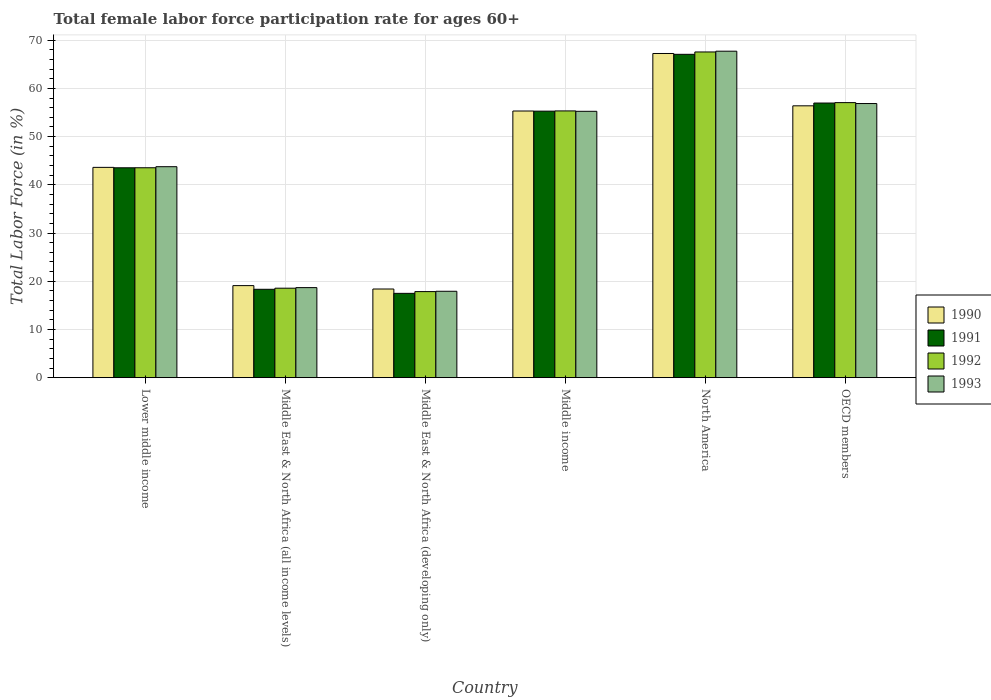What is the label of the 2nd group of bars from the left?
Your answer should be compact. Middle East & North Africa (all income levels). In how many cases, is the number of bars for a given country not equal to the number of legend labels?
Make the answer very short. 0. What is the female labor force participation rate in 1991 in Middle East & North Africa (all income levels)?
Make the answer very short. 18.33. Across all countries, what is the maximum female labor force participation rate in 1993?
Provide a short and direct response. 67.71. Across all countries, what is the minimum female labor force participation rate in 1990?
Your response must be concise. 18.39. In which country was the female labor force participation rate in 1993 maximum?
Ensure brevity in your answer.  North America. In which country was the female labor force participation rate in 1993 minimum?
Your response must be concise. Middle East & North Africa (developing only). What is the total female labor force participation rate in 1992 in the graph?
Offer a very short reply. 259.87. What is the difference between the female labor force participation rate in 1992 in Lower middle income and that in North America?
Give a very brief answer. -24.01. What is the difference between the female labor force participation rate in 1991 in Middle East & North Africa (developing only) and the female labor force participation rate in 1992 in Middle income?
Make the answer very short. -37.84. What is the average female labor force participation rate in 1991 per country?
Your answer should be compact. 43.11. What is the difference between the female labor force participation rate of/in 1990 and female labor force participation rate of/in 1991 in Middle income?
Ensure brevity in your answer.  0.03. In how many countries, is the female labor force participation rate in 1992 greater than 52 %?
Offer a very short reply. 3. What is the ratio of the female labor force participation rate in 1993 in Middle East & North Africa (all income levels) to that in OECD members?
Your answer should be very brief. 0.33. Is the female labor force participation rate in 1990 in Middle East & North Africa (all income levels) less than that in Middle East & North Africa (developing only)?
Make the answer very short. No. Is the difference between the female labor force participation rate in 1990 in Middle East & North Africa (all income levels) and Middle East & North Africa (developing only) greater than the difference between the female labor force participation rate in 1991 in Middle East & North Africa (all income levels) and Middle East & North Africa (developing only)?
Offer a terse response. No. What is the difference between the highest and the second highest female labor force participation rate in 1992?
Give a very brief answer. -10.51. What is the difference between the highest and the lowest female labor force participation rate in 1992?
Provide a succinct answer. 49.7. Is it the case that in every country, the sum of the female labor force participation rate in 1992 and female labor force participation rate in 1993 is greater than the female labor force participation rate in 1990?
Make the answer very short. Yes. How many countries are there in the graph?
Your answer should be very brief. 6. What is the difference between two consecutive major ticks on the Y-axis?
Ensure brevity in your answer.  10. Are the values on the major ticks of Y-axis written in scientific E-notation?
Your answer should be very brief. No. How many legend labels are there?
Your answer should be very brief. 4. How are the legend labels stacked?
Offer a very short reply. Vertical. What is the title of the graph?
Make the answer very short. Total female labor force participation rate for ages 60+. What is the label or title of the Y-axis?
Give a very brief answer. Total Labor Force (in %). What is the Total Labor Force (in %) of 1990 in Lower middle income?
Your answer should be compact. 43.62. What is the Total Labor Force (in %) in 1991 in Lower middle income?
Your answer should be compact. 43.53. What is the Total Labor Force (in %) in 1992 in Lower middle income?
Provide a succinct answer. 43.54. What is the Total Labor Force (in %) in 1993 in Lower middle income?
Give a very brief answer. 43.76. What is the Total Labor Force (in %) of 1990 in Middle East & North Africa (all income levels)?
Ensure brevity in your answer.  19.09. What is the Total Labor Force (in %) in 1991 in Middle East & North Africa (all income levels)?
Offer a very short reply. 18.33. What is the Total Labor Force (in %) of 1992 in Middle East & North Africa (all income levels)?
Your response must be concise. 18.56. What is the Total Labor Force (in %) in 1993 in Middle East & North Africa (all income levels)?
Offer a very short reply. 18.68. What is the Total Labor Force (in %) of 1990 in Middle East & North Africa (developing only)?
Offer a terse response. 18.39. What is the Total Labor Force (in %) in 1991 in Middle East & North Africa (developing only)?
Make the answer very short. 17.49. What is the Total Labor Force (in %) in 1992 in Middle East & North Africa (developing only)?
Your answer should be very brief. 17.85. What is the Total Labor Force (in %) in 1993 in Middle East & North Africa (developing only)?
Offer a terse response. 17.92. What is the Total Labor Force (in %) of 1990 in Middle income?
Your response must be concise. 55.31. What is the Total Labor Force (in %) in 1991 in Middle income?
Your response must be concise. 55.28. What is the Total Labor Force (in %) of 1992 in Middle income?
Keep it short and to the point. 55.33. What is the Total Labor Force (in %) in 1993 in Middle income?
Provide a succinct answer. 55.24. What is the Total Labor Force (in %) of 1990 in North America?
Provide a short and direct response. 67.23. What is the Total Labor Force (in %) in 1991 in North America?
Your answer should be compact. 67.06. What is the Total Labor Force (in %) of 1992 in North America?
Keep it short and to the point. 67.55. What is the Total Labor Force (in %) in 1993 in North America?
Offer a very short reply. 67.71. What is the Total Labor Force (in %) in 1990 in OECD members?
Offer a very short reply. 56.38. What is the Total Labor Force (in %) of 1991 in OECD members?
Your answer should be compact. 56.96. What is the Total Labor Force (in %) in 1992 in OECD members?
Your answer should be compact. 57.05. What is the Total Labor Force (in %) of 1993 in OECD members?
Offer a terse response. 56.86. Across all countries, what is the maximum Total Labor Force (in %) in 1990?
Offer a very short reply. 67.23. Across all countries, what is the maximum Total Labor Force (in %) in 1991?
Offer a terse response. 67.06. Across all countries, what is the maximum Total Labor Force (in %) in 1992?
Make the answer very short. 67.55. Across all countries, what is the maximum Total Labor Force (in %) of 1993?
Keep it short and to the point. 67.71. Across all countries, what is the minimum Total Labor Force (in %) in 1990?
Provide a short and direct response. 18.39. Across all countries, what is the minimum Total Labor Force (in %) in 1991?
Keep it short and to the point. 17.49. Across all countries, what is the minimum Total Labor Force (in %) in 1992?
Provide a short and direct response. 17.85. Across all countries, what is the minimum Total Labor Force (in %) in 1993?
Ensure brevity in your answer.  17.92. What is the total Total Labor Force (in %) in 1990 in the graph?
Give a very brief answer. 260.01. What is the total Total Labor Force (in %) in 1991 in the graph?
Provide a short and direct response. 258.64. What is the total Total Labor Force (in %) in 1992 in the graph?
Your answer should be very brief. 259.87. What is the total Total Labor Force (in %) in 1993 in the graph?
Provide a short and direct response. 260.16. What is the difference between the Total Labor Force (in %) of 1990 in Lower middle income and that in Middle East & North Africa (all income levels)?
Ensure brevity in your answer.  24.53. What is the difference between the Total Labor Force (in %) of 1991 in Lower middle income and that in Middle East & North Africa (all income levels)?
Provide a succinct answer. 25.2. What is the difference between the Total Labor Force (in %) in 1992 in Lower middle income and that in Middle East & North Africa (all income levels)?
Provide a succinct answer. 24.98. What is the difference between the Total Labor Force (in %) in 1993 in Lower middle income and that in Middle East & North Africa (all income levels)?
Offer a terse response. 25.08. What is the difference between the Total Labor Force (in %) in 1990 in Lower middle income and that in Middle East & North Africa (developing only)?
Give a very brief answer. 25.23. What is the difference between the Total Labor Force (in %) of 1991 in Lower middle income and that in Middle East & North Africa (developing only)?
Your answer should be very brief. 26.04. What is the difference between the Total Labor Force (in %) of 1992 in Lower middle income and that in Middle East & North Africa (developing only)?
Provide a short and direct response. 25.69. What is the difference between the Total Labor Force (in %) in 1993 in Lower middle income and that in Middle East & North Africa (developing only)?
Your answer should be very brief. 25.84. What is the difference between the Total Labor Force (in %) of 1990 in Lower middle income and that in Middle income?
Your response must be concise. -11.69. What is the difference between the Total Labor Force (in %) in 1991 in Lower middle income and that in Middle income?
Offer a terse response. -11.75. What is the difference between the Total Labor Force (in %) in 1992 in Lower middle income and that in Middle income?
Provide a succinct answer. -11.79. What is the difference between the Total Labor Force (in %) in 1993 in Lower middle income and that in Middle income?
Give a very brief answer. -11.49. What is the difference between the Total Labor Force (in %) in 1990 in Lower middle income and that in North America?
Provide a short and direct response. -23.62. What is the difference between the Total Labor Force (in %) of 1991 in Lower middle income and that in North America?
Give a very brief answer. -23.53. What is the difference between the Total Labor Force (in %) of 1992 in Lower middle income and that in North America?
Your response must be concise. -24.01. What is the difference between the Total Labor Force (in %) of 1993 in Lower middle income and that in North America?
Ensure brevity in your answer.  -23.95. What is the difference between the Total Labor Force (in %) in 1990 in Lower middle income and that in OECD members?
Ensure brevity in your answer.  -12.76. What is the difference between the Total Labor Force (in %) in 1991 in Lower middle income and that in OECD members?
Your response must be concise. -13.43. What is the difference between the Total Labor Force (in %) of 1992 in Lower middle income and that in OECD members?
Your answer should be compact. -13.51. What is the difference between the Total Labor Force (in %) of 1993 in Lower middle income and that in OECD members?
Make the answer very short. -13.1. What is the difference between the Total Labor Force (in %) in 1990 in Middle East & North Africa (all income levels) and that in Middle East & North Africa (developing only)?
Your answer should be very brief. 0.7. What is the difference between the Total Labor Force (in %) in 1991 in Middle East & North Africa (all income levels) and that in Middle East & North Africa (developing only)?
Give a very brief answer. 0.84. What is the difference between the Total Labor Force (in %) in 1992 in Middle East & North Africa (all income levels) and that in Middle East & North Africa (developing only)?
Provide a succinct answer. 0.71. What is the difference between the Total Labor Force (in %) of 1993 in Middle East & North Africa (all income levels) and that in Middle East & North Africa (developing only)?
Keep it short and to the point. 0.76. What is the difference between the Total Labor Force (in %) in 1990 in Middle East & North Africa (all income levels) and that in Middle income?
Ensure brevity in your answer.  -36.21. What is the difference between the Total Labor Force (in %) in 1991 in Middle East & North Africa (all income levels) and that in Middle income?
Make the answer very short. -36.95. What is the difference between the Total Labor Force (in %) of 1992 in Middle East & North Africa (all income levels) and that in Middle income?
Offer a terse response. -36.77. What is the difference between the Total Labor Force (in %) in 1993 in Middle East & North Africa (all income levels) and that in Middle income?
Provide a short and direct response. -36.57. What is the difference between the Total Labor Force (in %) of 1990 in Middle East & North Africa (all income levels) and that in North America?
Provide a succinct answer. -48.14. What is the difference between the Total Labor Force (in %) of 1991 in Middle East & North Africa (all income levels) and that in North America?
Give a very brief answer. -48.73. What is the difference between the Total Labor Force (in %) in 1992 in Middle East & North Africa (all income levels) and that in North America?
Offer a very short reply. -48.99. What is the difference between the Total Labor Force (in %) of 1993 in Middle East & North Africa (all income levels) and that in North America?
Your answer should be compact. -49.03. What is the difference between the Total Labor Force (in %) in 1990 in Middle East & North Africa (all income levels) and that in OECD members?
Offer a terse response. -37.29. What is the difference between the Total Labor Force (in %) of 1991 in Middle East & North Africa (all income levels) and that in OECD members?
Make the answer very short. -38.63. What is the difference between the Total Labor Force (in %) of 1992 in Middle East & North Africa (all income levels) and that in OECD members?
Offer a terse response. -38.49. What is the difference between the Total Labor Force (in %) of 1993 in Middle East & North Africa (all income levels) and that in OECD members?
Your answer should be compact. -38.18. What is the difference between the Total Labor Force (in %) of 1990 in Middle East & North Africa (developing only) and that in Middle income?
Make the answer very short. -36.92. What is the difference between the Total Labor Force (in %) of 1991 in Middle East & North Africa (developing only) and that in Middle income?
Provide a short and direct response. -37.79. What is the difference between the Total Labor Force (in %) of 1992 in Middle East & North Africa (developing only) and that in Middle income?
Ensure brevity in your answer.  -37.48. What is the difference between the Total Labor Force (in %) of 1993 in Middle East & North Africa (developing only) and that in Middle income?
Provide a short and direct response. -37.32. What is the difference between the Total Labor Force (in %) in 1990 in Middle East & North Africa (developing only) and that in North America?
Your answer should be compact. -48.85. What is the difference between the Total Labor Force (in %) of 1991 in Middle East & North Africa (developing only) and that in North America?
Your response must be concise. -49.58. What is the difference between the Total Labor Force (in %) in 1992 in Middle East & North Africa (developing only) and that in North America?
Provide a short and direct response. -49.7. What is the difference between the Total Labor Force (in %) of 1993 in Middle East & North Africa (developing only) and that in North America?
Provide a succinct answer. -49.79. What is the difference between the Total Labor Force (in %) of 1990 in Middle East & North Africa (developing only) and that in OECD members?
Keep it short and to the point. -38. What is the difference between the Total Labor Force (in %) in 1991 in Middle East & North Africa (developing only) and that in OECD members?
Keep it short and to the point. -39.47. What is the difference between the Total Labor Force (in %) in 1992 in Middle East & North Africa (developing only) and that in OECD members?
Provide a succinct answer. -39.2. What is the difference between the Total Labor Force (in %) in 1993 in Middle East & North Africa (developing only) and that in OECD members?
Keep it short and to the point. -38.94. What is the difference between the Total Labor Force (in %) of 1990 in Middle income and that in North America?
Provide a succinct answer. -11.93. What is the difference between the Total Labor Force (in %) in 1991 in Middle income and that in North America?
Provide a succinct answer. -11.79. What is the difference between the Total Labor Force (in %) in 1992 in Middle income and that in North America?
Your response must be concise. -12.23. What is the difference between the Total Labor Force (in %) in 1993 in Middle income and that in North America?
Your answer should be very brief. -12.47. What is the difference between the Total Labor Force (in %) in 1990 in Middle income and that in OECD members?
Offer a terse response. -1.08. What is the difference between the Total Labor Force (in %) in 1991 in Middle income and that in OECD members?
Keep it short and to the point. -1.68. What is the difference between the Total Labor Force (in %) in 1992 in Middle income and that in OECD members?
Ensure brevity in your answer.  -1.72. What is the difference between the Total Labor Force (in %) of 1993 in Middle income and that in OECD members?
Your response must be concise. -1.61. What is the difference between the Total Labor Force (in %) of 1990 in North America and that in OECD members?
Provide a succinct answer. 10.85. What is the difference between the Total Labor Force (in %) of 1991 in North America and that in OECD members?
Provide a short and direct response. 10.11. What is the difference between the Total Labor Force (in %) in 1992 in North America and that in OECD members?
Give a very brief answer. 10.51. What is the difference between the Total Labor Force (in %) of 1993 in North America and that in OECD members?
Keep it short and to the point. 10.85. What is the difference between the Total Labor Force (in %) in 1990 in Lower middle income and the Total Labor Force (in %) in 1991 in Middle East & North Africa (all income levels)?
Ensure brevity in your answer.  25.29. What is the difference between the Total Labor Force (in %) of 1990 in Lower middle income and the Total Labor Force (in %) of 1992 in Middle East & North Africa (all income levels)?
Offer a terse response. 25.06. What is the difference between the Total Labor Force (in %) of 1990 in Lower middle income and the Total Labor Force (in %) of 1993 in Middle East & North Africa (all income levels)?
Make the answer very short. 24.94. What is the difference between the Total Labor Force (in %) of 1991 in Lower middle income and the Total Labor Force (in %) of 1992 in Middle East & North Africa (all income levels)?
Your answer should be very brief. 24.97. What is the difference between the Total Labor Force (in %) in 1991 in Lower middle income and the Total Labor Force (in %) in 1993 in Middle East & North Africa (all income levels)?
Offer a terse response. 24.85. What is the difference between the Total Labor Force (in %) of 1992 in Lower middle income and the Total Labor Force (in %) of 1993 in Middle East & North Africa (all income levels)?
Your answer should be compact. 24.86. What is the difference between the Total Labor Force (in %) of 1990 in Lower middle income and the Total Labor Force (in %) of 1991 in Middle East & North Africa (developing only)?
Provide a short and direct response. 26.13. What is the difference between the Total Labor Force (in %) in 1990 in Lower middle income and the Total Labor Force (in %) in 1992 in Middle East & North Africa (developing only)?
Provide a succinct answer. 25.77. What is the difference between the Total Labor Force (in %) of 1990 in Lower middle income and the Total Labor Force (in %) of 1993 in Middle East & North Africa (developing only)?
Make the answer very short. 25.7. What is the difference between the Total Labor Force (in %) in 1991 in Lower middle income and the Total Labor Force (in %) in 1992 in Middle East & North Africa (developing only)?
Your response must be concise. 25.68. What is the difference between the Total Labor Force (in %) in 1991 in Lower middle income and the Total Labor Force (in %) in 1993 in Middle East & North Africa (developing only)?
Offer a terse response. 25.61. What is the difference between the Total Labor Force (in %) in 1992 in Lower middle income and the Total Labor Force (in %) in 1993 in Middle East & North Africa (developing only)?
Give a very brief answer. 25.62. What is the difference between the Total Labor Force (in %) in 1990 in Lower middle income and the Total Labor Force (in %) in 1991 in Middle income?
Provide a succinct answer. -11.66. What is the difference between the Total Labor Force (in %) of 1990 in Lower middle income and the Total Labor Force (in %) of 1992 in Middle income?
Provide a succinct answer. -11.71. What is the difference between the Total Labor Force (in %) in 1990 in Lower middle income and the Total Labor Force (in %) in 1993 in Middle income?
Provide a succinct answer. -11.63. What is the difference between the Total Labor Force (in %) in 1991 in Lower middle income and the Total Labor Force (in %) in 1992 in Middle income?
Your answer should be very brief. -11.8. What is the difference between the Total Labor Force (in %) of 1991 in Lower middle income and the Total Labor Force (in %) of 1993 in Middle income?
Offer a very short reply. -11.71. What is the difference between the Total Labor Force (in %) of 1992 in Lower middle income and the Total Labor Force (in %) of 1993 in Middle income?
Keep it short and to the point. -11.71. What is the difference between the Total Labor Force (in %) in 1990 in Lower middle income and the Total Labor Force (in %) in 1991 in North America?
Keep it short and to the point. -23.45. What is the difference between the Total Labor Force (in %) in 1990 in Lower middle income and the Total Labor Force (in %) in 1992 in North America?
Offer a terse response. -23.93. What is the difference between the Total Labor Force (in %) in 1990 in Lower middle income and the Total Labor Force (in %) in 1993 in North America?
Your response must be concise. -24.09. What is the difference between the Total Labor Force (in %) in 1991 in Lower middle income and the Total Labor Force (in %) in 1992 in North America?
Your answer should be compact. -24.02. What is the difference between the Total Labor Force (in %) of 1991 in Lower middle income and the Total Labor Force (in %) of 1993 in North America?
Your answer should be very brief. -24.18. What is the difference between the Total Labor Force (in %) in 1992 in Lower middle income and the Total Labor Force (in %) in 1993 in North America?
Keep it short and to the point. -24.17. What is the difference between the Total Labor Force (in %) of 1990 in Lower middle income and the Total Labor Force (in %) of 1991 in OECD members?
Keep it short and to the point. -13.34. What is the difference between the Total Labor Force (in %) in 1990 in Lower middle income and the Total Labor Force (in %) in 1992 in OECD members?
Your answer should be very brief. -13.43. What is the difference between the Total Labor Force (in %) of 1990 in Lower middle income and the Total Labor Force (in %) of 1993 in OECD members?
Your answer should be very brief. -13.24. What is the difference between the Total Labor Force (in %) in 1991 in Lower middle income and the Total Labor Force (in %) in 1992 in OECD members?
Offer a terse response. -13.52. What is the difference between the Total Labor Force (in %) in 1991 in Lower middle income and the Total Labor Force (in %) in 1993 in OECD members?
Give a very brief answer. -13.33. What is the difference between the Total Labor Force (in %) of 1992 in Lower middle income and the Total Labor Force (in %) of 1993 in OECD members?
Ensure brevity in your answer.  -13.32. What is the difference between the Total Labor Force (in %) in 1990 in Middle East & North Africa (all income levels) and the Total Labor Force (in %) in 1991 in Middle East & North Africa (developing only)?
Provide a short and direct response. 1.6. What is the difference between the Total Labor Force (in %) in 1990 in Middle East & North Africa (all income levels) and the Total Labor Force (in %) in 1992 in Middle East & North Africa (developing only)?
Provide a succinct answer. 1.24. What is the difference between the Total Labor Force (in %) in 1990 in Middle East & North Africa (all income levels) and the Total Labor Force (in %) in 1993 in Middle East & North Africa (developing only)?
Give a very brief answer. 1.17. What is the difference between the Total Labor Force (in %) in 1991 in Middle East & North Africa (all income levels) and the Total Labor Force (in %) in 1992 in Middle East & North Africa (developing only)?
Your response must be concise. 0.48. What is the difference between the Total Labor Force (in %) of 1991 in Middle East & North Africa (all income levels) and the Total Labor Force (in %) of 1993 in Middle East & North Africa (developing only)?
Provide a succinct answer. 0.41. What is the difference between the Total Labor Force (in %) in 1992 in Middle East & North Africa (all income levels) and the Total Labor Force (in %) in 1993 in Middle East & North Africa (developing only)?
Your answer should be compact. 0.64. What is the difference between the Total Labor Force (in %) of 1990 in Middle East & North Africa (all income levels) and the Total Labor Force (in %) of 1991 in Middle income?
Your response must be concise. -36.19. What is the difference between the Total Labor Force (in %) in 1990 in Middle East & North Africa (all income levels) and the Total Labor Force (in %) in 1992 in Middle income?
Ensure brevity in your answer.  -36.23. What is the difference between the Total Labor Force (in %) in 1990 in Middle East & North Africa (all income levels) and the Total Labor Force (in %) in 1993 in Middle income?
Provide a short and direct response. -36.15. What is the difference between the Total Labor Force (in %) in 1991 in Middle East & North Africa (all income levels) and the Total Labor Force (in %) in 1992 in Middle income?
Give a very brief answer. -37. What is the difference between the Total Labor Force (in %) of 1991 in Middle East & North Africa (all income levels) and the Total Labor Force (in %) of 1993 in Middle income?
Your answer should be compact. -36.91. What is the difference between the Total Labor Force (in %) of 1992 in Middle East & North Africa (all income levels) and the Total Labor Force (in %) of 1993 in Middle income?
Your response must be concise. -36.69. What is the difference between the Total Labor Force (in %) of 1990 in Middle East & North Africa (all income levels) and the Total Labor Force (in %) of 1991 in North America?
Your answer should be very brief. -47.97. What is the difference between the Total Labor Force (in %) of 1990 in Middle East & North Africa (all income levels) and the Total Labor Force (in %) of 1992 in North America?
Your response must be concise. -48.46. What is the difference between the Total Labor Force (in %) of 1990 in Middle East & North Africa (all income levels) and the Total Labor Force (in %) of 1993 in North America?
Offer a very short reply. -48.62. What is the difference between the Total Labor Force (in %) in 1991 in Middle East & North Africa (all income levels) and the Total Labor Force (in %) in 1992 in North America?
Give a very brief answer. -49.22. What is the difference between the Total Labor Force (in %) of 1991 in Middle East & North Africa (all income levels) and the Total Labor Force (in %) of 1993 in North America?
Give a very brief answer. -49.38. What is the difference between the Total Labor Force (in %) of 1992 in Middle East & North Africa (all income levels) and the Total Labor Force (in %) of 1993 in North America?
Offer a very short reply. -49.15. What is the difference between the Total Labor Force (in %) in 1990 in Middle East & North Africa (all income levels) and the Total Labor Force (in %) in 1991 in OECD members?
Provide a short and direct response. -37.87. What is the difference between the Total Labor Force (in %) in 1990 in Middle East & North Africa (all income levels) and the Total Labor Force (in %) in 1992 in OECD members?
Your response must be concise. -37.95. What is the difference between the Total Labor Force (in %) in 1990 in Middle East & North Africa (all income levels) and the Total Labor Force (in %) in 1993 in OECD members?
Provide a succinct answer. -37.76. What is the difference between the Total Labor Force (in %) in 1991 in Middle East & North Africa (all income levels) and the Total Labor Force (in %) in 1992 in OECD members?
Your answer should be compact. -38.72. What is the difference between the Total Labor Force (in %) of 1991 in Middle East & North Africa (all income levels) and the Total Labor Force (in %) of 1993 in OECD members?
Give a very brief answer. -38.53. What is the difference between the Total Labor Force (in %) of 1992 in Middle East & North Africa (all income levels) and the Total Labor Force (in %) of 1993 in OECD members?
Give a very brief answer. -38.3. What is the difference between the Total Labor Force (in %) in 1990 in Middle East & North Africa (developing only) and the Total Labor Force (in %) in 1991 in Middle income?
Offer a very short reply. -36.89. What is the difference between the Total Labor Force (in %) in 1990 in Middle East & North Africa (developing only) and the Total Labor Force (in %) in 1992 in Middle income?
Provide a succinct answer. -36.94. What is the difference between the Total Labor Force (in %) of 1990 in Middle East & North Africa (developing only) and the Total Labor Force (in %) of 1993 in Middle income?
Ensure brevity in your answer.  -36.86. What is the difference between the Total Labor Force (in %) in 1991 in Middle East & North Africa (developing only) and the Total Labor Force (in %) in 1992 in Middle income?
Provide a succinct answer. -37.84. What is the difference between the Total Labor Force (in %) of 1991 in Middle East & North Africa (developing only) and the Total Labor Force (in %) of 1993 in Middle income?
Your answer should be compact. -37.76. What is the difference between the Total Labor Force (in %) in 1992 in Middle East & North Africa (developing only) and the Total Labor Force (in %) in 1993 in Middle income?
Give a very brief answer. -37.39. What is the difference between the Total Labor Force (in %) in 1990 in Middle East & North Africa (developing only) and the Total Labor Force (in %) in 1991 in North America?
Offer a terse response. -48.68. What is the difference between the Total Labor Force (in %) of 1990 in Middle East & North Africa (developing only) and the Total Labor Force (in %) of 1992 in North America?
Offer a very short reply. -49.16. What is the difference between the Total Labor Force (in %) of 1990 in Middle East & North Africa (developing only) and the Total Labor Force (in %) of 1993 in North America?
Your answer should be very brief. -49.32. What is the difference between the Total Labor Force (in %) of 1991 in Middle East & North Africa (developing only) and the Total Labor Force (in %) of 1992 in North America?
Keep it short and to the point. -50.06. What is the difference between the Total Labor Force (in %) of 1991 in Middle East & North Africa (developing only) and the Total Labor Force (in %) of 1993 in North America?
Keep it short and to the point. -50.22. What is the difference between the Total Labor Force (in %) of 1992 in Middle East & North Africa (developing only) and the Total Labor Force (in %) of 1993 in North America?
Keep it short and to the point. -49.86. What is the difference between the Total Labor Force (in %) of 1990 in Middle East & North Africa (developing only) and the Total Labor Force (in %) of 1991 in OECD members?
Your answer should be very brief. -38.57. What is the difference between the Total Labor Force (in %) of 1990 in Middle East & North Africa (developing only) and the Total Labor Force (in %) of 1992 in OECD members?
Make the answer very short. -38.66. What is the difference between the Total Labor Force (in %) in 1990 in Middle East & North Africa (developing only) and the Total Labor Force (in %) in 1993 in OECD members?
Keep it short and to the point. -38.47. What is the difference between the Total Labor Force (in %) of 1991 in Middle East & North Africa (developing only) and the Total Labor Force (in %) of 1992 in OECD members?
Your answer should be very brief. -39.56. What is the difference between the Total Labor Force (in %) in 1991 in Middle East & North Africa (developing only) and the Total Labor Force (in %) in 1993 in OECD members?
Give a very brief answer. -39.37. What is the difference between the Total Labor Force (in %) of 1992 in Middle East & North Africa (developing only) and the Total Labor Force (in %) of 1993 in OECD members?
Give a very brief answer. -39.01. What is the difference between the Total Labor Force (in %) in 1990 in Middle income and the Total Labor Force (in %) in 1991 in North America?
Ensure brevity in your answer.  -11.76. What is the difference between the Total Labor Force (in %) in 1990 in Middle income and the Total Labor Force (in %) in 1992 in North America?
Keep it short and to the point. -12.25. What is the difference between the Total Labor Force (in %) in 1990 in Middle income and the Total Labor Force (in %) in 1993 in North America?
Offer a terse response. -12.4. What is the difference between the Total Labor Force (in %) of 1991 in Middle income and the Total Labor Force (in %) of 1992 in North America?
Provide a succinct answer. -12.27. What is the difference between the Total Labor Force (in %) in 1991 in Middle income and the Total Labor Force (in %) in 1993 in North America?
Provide a succinct answer. -12.43. What is the difference between the Total Labor Force (in %) of 1992 in Middle income and the Total Labor Force (in %) of 1993 in North America?
Your answer should be very brief. -12.38. What is the difference between the Total Labor Force (in %) in 1990 in Middle income and the Total Labor Force (in %) in 1991 in OECD members?
Your answer should be very brief. -1.65. What is the difference between the Total Labor Force (in %) of 1990 in Middle income and the Total Labor Force (in %) of 1992 in OECD members?
Keep it short and to the point. -1.74. What is the difference between the Total Labor Force (in %) of 1990 in Middle income and the Total Labor Force (in %) of 1993 in OECD members?
Your answer should be compact. -1.55. What is the difference between the Total Labor Force (in %) in 1991 in Middle income and the Total Labor Force (in %) in 1992 in OECD members?
Provide a short and direct response. -1.77. What is the difference between the Total Labor Force (in %) in 1991 in Middle income and the Total Labor Force (in %) in 1993 in OECD members?
Your answer should be very brief. -1.58. What is the difference between the Total Labor Force (in %) of 1992 in Middle income and the Total Labor Force (in %) of 1993 in OECD members?
Ensure brevity in your answer.  -1.53. What is the difference between the Total Labor Force (in %) in 1990 in North America and the Total Labor Force (in %) in 1991 in OECD members?
Make the answer very short. 10.28. What is the difference between the Total Labor Force (in %) of 1990 in North America and the Total Labor Force (in %) of 1992 in OECD members?
Provide a succinct answer. 10.19. What is the difference between the Total Labor Force (in %) of 1990 in North America and the Total Labor Force (in %) of 1993 in OECD members?
Your answer should be compact. 10.38. What is the difference between the Total Labor Force (in %) of 1991 in North America and the Total Labor Force (in %) of 1992 in OECD members?
Make the answer very short. 10.02. What is the difference between the Total Labor Force (in %) of 1991 in North America and the Total Labor Force (in %) of 1993 in OECD members?
Provide a succinct answer. 10.21. What is the difference between the Total Labor Force (in %) in 1992 in North America and the Total Labor Force (in %) in 1993 in OECD members?
Provide a short and direct response. 10.7. What is the average Total Labor Force (in %) of 1990 per country?
Your response must be concise. 43.34. What is the average Total Labor Force (in %) of 1991 per country?
Your answer should be compact. 43.11. What is the average Total Labor Force (in %) in 1992 per country?
Keep it short and to the point. 43.31. What is the average Total Labor Force (in %) of 1993 per country?
Offer a very short reply. 43.36. What is the difference between the Total Labor Force (in %) of 1990 and Total Labor Force (in %) of 1991 in Lower middle income?
Make the answer very short. 0.09. What is the difference between the Total Labor Force (in %) of 1990 and Total Labor Force (in %) of 1993 in Lower middle income?
Your answer should be very brief. -0.14. What is the difference between the Total Labor Force (in %) of 1991 and Total Labor Force (in %) of 1992 in Lower middle income?
Give a very brief answer. -0.01. What is the difference between the Total Labor Force (in %) of 1991 and Total Labor Force (in %) of 1993 in Lower middle income?
Make the answer very short. -0.23. What is the difference between the Total Labor Force (in %) of 1992 and Total Labor Force (in %) of 1993 in Lower middle income?
Your response must be concise. -0.22. What is the difference between the Total Labor Force (in %) in 1990 and Total Labor Force (in %) in 1991 in Middle East & North Africa (all income levels)?
Provide a short and direct response. 0.76. What is the difference between the Total Labor Force (in %) of 1990 and Total Labor Force (in %) of 1992 in Middle East & North Africa (all income levels)?
Provide a short and direct response. 0.53. What is the difference between the Total Labor Force (in %) of 1990 and Total Labor Force (in %) of 1993 in Middle East & North Africa (all income levels)?
Ensure brevity in your answer.  0.41. What is the difference between the Total Labor Force (in %) of 1991 and Total Labor Force (in %) of 1992 in Middle East & North Africa (all income levels)?
Offer a very short reply. -0.23. What is the difference between the Total Labor Force (in %) in 1991 and Total Labor Force (in %) in 1993 in Middle East & North Africa (all income levels)?
Your response must be concise. -0.35. What is the difference between the Total Labor Force (in %) of 1992 and Total Labor Force (in %) of 1993 in Middle East & North Africa (all income levels)?
Your response must be concise. -0.12. What is the difference between the Total Labor Force (in %) in 1990 and Total Labor Force (in %) in 1991 in Middle East & North Africa (developing only)?
Your answer should be compact. 0.9. What is the difference between the Total Labor Force (in %) in 1990 and Total Labor Force (in %) in 1992 in Middle East & North Africa (developing only)?
Offer a very short reply. 0.54. What is the difference between the Total Labor Force (in %) of 1990 and Total Labor Force (in %) of 1993 in Middle East & North Africa (developing only)?
Your answer should be very brief. 0.47. What is the difference between the Total Labor Force (in %) of 1991 and Total Labor Force (in %) of 1992 in Middle East & North Africa (developing only)?
Give a very brief answer. -0.36. What is the difference between the Total Labor Force (in %) of 1991 and Total Labor Force (in %) of 1993 in Middle East & North Africa (developing only)?
Ensure brevity in your answer.  -0.43. What is the difference between the Total Labor Force (in %) of 1992 and Total Labor Force (in %) of 1993 in Middle East & North Africa (developing only)?
Keep it short and to the point. -0.07. What is the difference between the Total Labor Force (in %) in 1990 and Total Labor Force (in %) in 1991 in Middle income?
Offer a very short reply. 0.03. What is the difference between the Total Labor Force (in %) in 1990 and Total Labor Force (in %) in 1992 in Middle income?
Provide a succinct answer. -0.02. What is the difference between the Total Labor Force (in %) of 1990 and Total Labor Force (in %) of 1993 in Middle income?
Make the answer very short. 0.06. What is the difference between the Total Labor Force (in %) of 1991 and Total Labor Force (in %) of 1992 in Middle income?
Keep it short and to the point. -0.05. What is the difference between the Total Labor Force (in %) of 1991 and Total Labor Force (in %) of 1993 in Middle income?
Your answer should be very brief. 0.03. What is the difference between the Total Labor Force (in %) of 1992 and Total Labor Force (in %) of 1993 in Middle income?
Give a very brief answer. 0.08. What is the difference between the Total Labor Force (in %) in 1990 and Total Labor Force (in %) in 1991 in North America?
Offer a very short reply. 0.17. What is the difference between the Total Labor Force (in %) in 1990 and Total Labor Force (in %) in 1992 in North America?
Offer a very short reply. -0.32. What is the difference between the Total Labor Force (in %) of 1990 and Total Labor Force (in %) of 1993 in North America?
Offer a terse response. -0.48. What is the difference between the Total Labor Force (in %) of 1991 and Total Labor Force (in %) of 1992 in North America?
Keep it short and to the point. -0.49. What is the difference between the Total Labor Force (in %) in 1991 and Total Labor Force (in %) in 1993 in North America?
Your answer should be very brief. -0.65. What is the difference between the Total Labor Force (in %) of 1992 and Total Labor Force (in %) of 1993 in North America?
Offer a terse response. -0.16. What is the difference between the Total Labor Force (in %) of 1990 and Total Labor Force (in %) of 1991 in OECD members?
Make the answer very short. -0.58. What is the difference between the Total Labor Force (in %) of 1990 and Total Labor Force (in %) of 1992 in OECD members?
Offer a very short reply. -0.66. What is the difference between the Total Labor Force (in %) of 1990 and Total Labor Force (in %) of 1993 in OECD members?
Give a very brief answer. -0.47. What is the difference between the Total Labor Force (in %) of 1991 and Total Labor Force (in %) of 1992 in OECD members?
Offer a terse response. -0.09. What is the difference between the Total Labor Force (in %) in 1991 and Total Labor Force (in %) in 1993 in OECD members?
Provide a succinct answer. 0.1. What is the difference between the Total Labor Force (in %) in 1992 and Total Labor Force (in %) in 1993 in OECD members?
Provide a succinct answer. 0.19. What is the ratio of the Total Labor Force (in %) of 1990 in Lower middle income to that in Middle East & North Africa (all income levels)?
Ensure brevity in your answer.  2.28. What is the ratio of the Total Labor Force (in %) of 1991 in Lower middle income to that in Middle East & North Africa (all income levels)?
Provide a succinct answer. 2.37. What is the ratio of the Total Labor Force (in %) of 1992 in Lower middle income to that in Middle East & North Africa (all income levels)?
Your answer should be very brief. 2.35. What is the ratio of the Total Labor Force (in %) in 1993 in Lower middle income to that in Middle East & North Africa (all income levels)?
Provide a short and direct response. 2.34. What is the ratio of the Total Labor Force (in %) of 1990 in Lower middle income to that in Middle East & North Africa (developing only)?
Offer a terse response. 2.37. What is the ratio of the Total Labor Force (in %) of 1991 in Lower middle income to that in Middle East & North Africa (developing only)?
Provide a short and direct response. 2.49. What is the ratio of the Total Labor Force (in %) of 1992 in Lower middle income to that in Middle East & North Africa (developing only)?
Provide a short and direct response. 2.44. What is the ratio of the Total Labor Force (in %) in 1993 in Lower middle income to that in Middle East & North Africa (developing only)?
Offer a terse response. 2.44. What is the ratio of the Total Labor Force (in %) of 1990 in Lower middle income to that in Middle income?
Make the answer very short. 0.79. What is the ratio of the Total Labor Force (in %) in 1991 in Lower middle income to that in Middle income?
Keep it short and to the point. 0.79. What is the ratio of the Total Labor Force (in %) in 1992 in Lower middle income to that in Middle income?
Provide a short and direct response. 0.79. What is the ratio of the Total Labor Force (in %) in 1993 in Lower middle income to that in Middle income?
Ensure brevity in your answer.  0.79. What is the ratio of the Total Labor Force (in %) in 1990 in Lower middle income to that in North America?
Provide a succinct answer. 0.65. What is the ratio of the Total Labor Force (in %) in 1991 in Lower middle income to that in North America?
Offer a very short reply. 0.65. What is the ratio of the Total Labor Force (in %) of 1992 in Lower middle income to that in North America?
Provide a succinct answer. 0.64. What is the ratio of the Total Labor Force (in %) of 1993 in Lower middle income to that in North America?
Keep it short and to the point. 0.65. What is the ratio of the Total Labor Force (in %) in 1990 in Lower middle income to that in OECD members?
Ensure brevity in your answer.  0.77. What is the ratio of the Total Labor Force (in %) in 1991 in Lower middle income to that in OECD members?
Your response must be concise. 0.76. What is the ratio of the Total Labor Force (in %) of 1992 in Lower middle income to that in OECD members?
Your answer should be very brief. 0.76. What is the ratio of the Total Labor Force (in %) in 1993 in Lower middle income to that in OECD members?
Ensure brevity in your answer.  0.77. What is the ratio of the Total Labor Force (in %) in 1990 in Middle East & North Africa (all income levels) to that in Middle East & North Africa (developing only)?
Ensure brevity in your answer.  1.04. What is the ratio of the Total Labor Force (in %) of 1991 in Middle East & North Africa (all income levels) to that in Middle East & North Africa (developing only)?
Offer a terse response. 1.05. What is the ratio of the Total Labor Force (in %) in 1992 in Middle East & North Africa (all income levels) to that in Middle East & North Africa (developing only)?
Keep it short and to the point. 1.04. What is the ratio of the Total Labor Force (in %) in 1993 in Middle East & North Africa (all income levels) to that in Middle East & North Africa (developing only)?
Provide a short and direct response. 1.04. What is the ratio of the Total Labor Force (in %) in 1990 in Middle East & North Africa (all income levels) to that in Middle income?
Provide a succinct answer. 0.35. What is the ratio of the Total Labor Force (in %) in 1991 in Middle East & North Africa (all income levels) to that in Middle income?
Your answer should be compact. 0.33. What is the ratio of the Total Labor Force (in %) of 1992 in Middle East & North Africa (all income levels) to that in Middle income?
Offer a terse response. 0.34. What is the ratio of the Total Labor Force (in %) of 1993 in Middle East & North Africa (all income levels) to that in Middle income?
Ensure brevity in your answer.  0.34. What is the ratio of the Total Labor Force (in %) of 1990 in Middle East & North Africa (all income levels) to that in North America?
Give a very brief answer. 0.28. What is the ratio of the Total Labor Force (in %) in 1991 in Middle East & North Africa (all income levels) to that in North America?
Make the answer very short. 0.27. What is the ratio of the Total Labor Force (in %) of 1992 in Middle East & North Africa (all income levels) to that in North America?
Your response must be concise. 0.27. What is the ratio of the Total Labor Force (in %) of 1993 in Middle East & North Africa (all income levels) to that in North America?
Offer a very short reply. 0.28. What is the ratio of the Total Labor Force (in %) in 1990 in Middle East & North Africa (all income levels) to that in OECD members?
Your response must be concise. 0.34. What is the ratio of the Total Labor Force (in %) in 1991 in Middle East & North Africa (all income levels) to that in OECD members?
Your answer should be compact. 0.32. What is the ratio of the Total Labor Force (in %) in 1992 in Middle East & North Africa (all income levels) to that in OECD members?
Give a very brief answer. 0.33. What is the ratio of the Total Labor Force (in %) in 1993 in Middle East & North Africa (all income levels) to that in OECD members?
Your response must be concise. 0.33. What is the ratio of the Total Labor Force (in %) in 1990 in Middle East & North Africa (developing only) to that in Middle income?
Your response must be concise. 0.33. What is the ratio of the Total Labor Force (in %) in 1991 in Middle East & North Africa (developing only) to that in Middle income?
Your answer should be very brief. 0.32. What is the ratio of the Total Labor Force (in %) of 1992 in Middle East & North Africa (developing only) to that in Middle income?
Ensure brevity in your answer.  0.32. What is the ratio of the Total Labor Force (in %) of 1993 in Middle East & North Africa (developing only) to that in Middle income?
Your response must be concise. 0.32. What is the ratio of the Total Labor Force (in %) of 1990 in Middle East & North Africa (developing only) to that in North America?
Give a very brief answer. 0.27. What is the ratio of the Total Labor Force (in %) in 1991 in Middle East & North Africa (developing only) to that in North America?
Keep it short and to the point. 0.26. What is the ratio of the Total Labor Force (in %) in 1992 in Middle East & North Africa (developing only) to that in North America?
Ensure brevity in your answer.  0.26. What is the ratio of the Total Labor Force (in %) in 1993 in Middle East & North Africa (developing only) to that in North America?
Your answer should be compact. 0.26. What is the ratio of the Total Labor Force (in %) of 1990 in Middle East & North Africa (developing only) to that in OECD members?
Your answer should be very brief. 0.33. What is the ratio of the Total Labor Force (in %) in 1991 in Middle East & North Africa (developing only) to that in OECD members?
Make the answer very short. 0.31. What is the ratio of the Total Labor Force (in %) of 1992 in Middle East & North Africa (developing only) to that in OECD members?
Give a very brief answer. 0.31. What is the ratio of the Total Labor Force (in %) in 1993 in Middle East & North Africa (developing only) to that in OECD members?
Your answer should be very brief. 0.32. What is the ratio of the Total Labor Force (in %) in 1990 in Middle income to that in North America?
Make the answer very short. 0.82. What is the ratio of the Total Labor Force (in %) of 1991 in Middle income to that in North America?
Provide a short and direct response. 0.82. What is the ratio of the Total Labor Force (in %) of 1992 in Middle income to that in North America?
Offer a terse response. 0.82. What is the ratio of the Total Labor Force (in %) in 1993 in Middle income to that in North America?
Your answer should be compact. 0.82. What is the ratio of the Total Labor Force (in %) of 1990 in Middle income to that in OECD members?
Ensure brevity in your answer.  0.98. What is the ratio of the Total Labor Force (in %) of 1991 in Middle income to that in OECD members?
Keep it short and to the point. 0.97. What is the ratio of the Total Labor Force (in %) of 1992 in Middle income to that in OECD members?
Make the answer very short. 0.97. What is the ratio of the Total Labor Force (in %) of 1993 in Middle income to that in OECD members?
Offer a very short reply. 0.97. What is the ratio of the Total Labor Force (in %) of 1990 in North America to that in OECD members?
Your response must be concise. 1.19. What is the ratio of the Total Labor Force (in %) in 1991 in North America to that in OECD members?
Offer a terse response. 1.18. What is the ratio of the Total Labor Force (in %) in 1992 in North America to that in OECD members?
Provide a succinct answer. 1.18. What is the ratio of the Total Labor Force (in %) in 1993 in North America to that in OECD members?
Offer a terse response. 1.19. What is the difference between the highest and the second highest Total Labor Force (in %) of 1990?
Ensure brevity in your answer.  10.85. What is the difference between the highest and the second highest Total Labor Force (in %) of 1991?
Keep it short and to the point. 10.11. What is the difference between the highest and the second highest Total Labor Force (in %) of 1992?
Ensure brevity in your answer.  10.51. What is the difference between the highest and the second highest Total Labor Force (in %) of 1993?
Provide a succinct answer. 10.85. What is the difference between the highest and the lowest Total Labor Force (in %) in 1990?
Your answer should be very brief. 48.85. What is the difference between the highest and the lowest Total Labor Force (in %) in 1991?
Provide a short and direct response. 49.58. What is the difference between the highest and the lowest Total Labor Force (in %) of 1992?
Your answer should be compact. 49.7. What is the difference between the highest and the lowest Total Labor Force (in %) of 1993?
Your response must be concise. 49.79. 